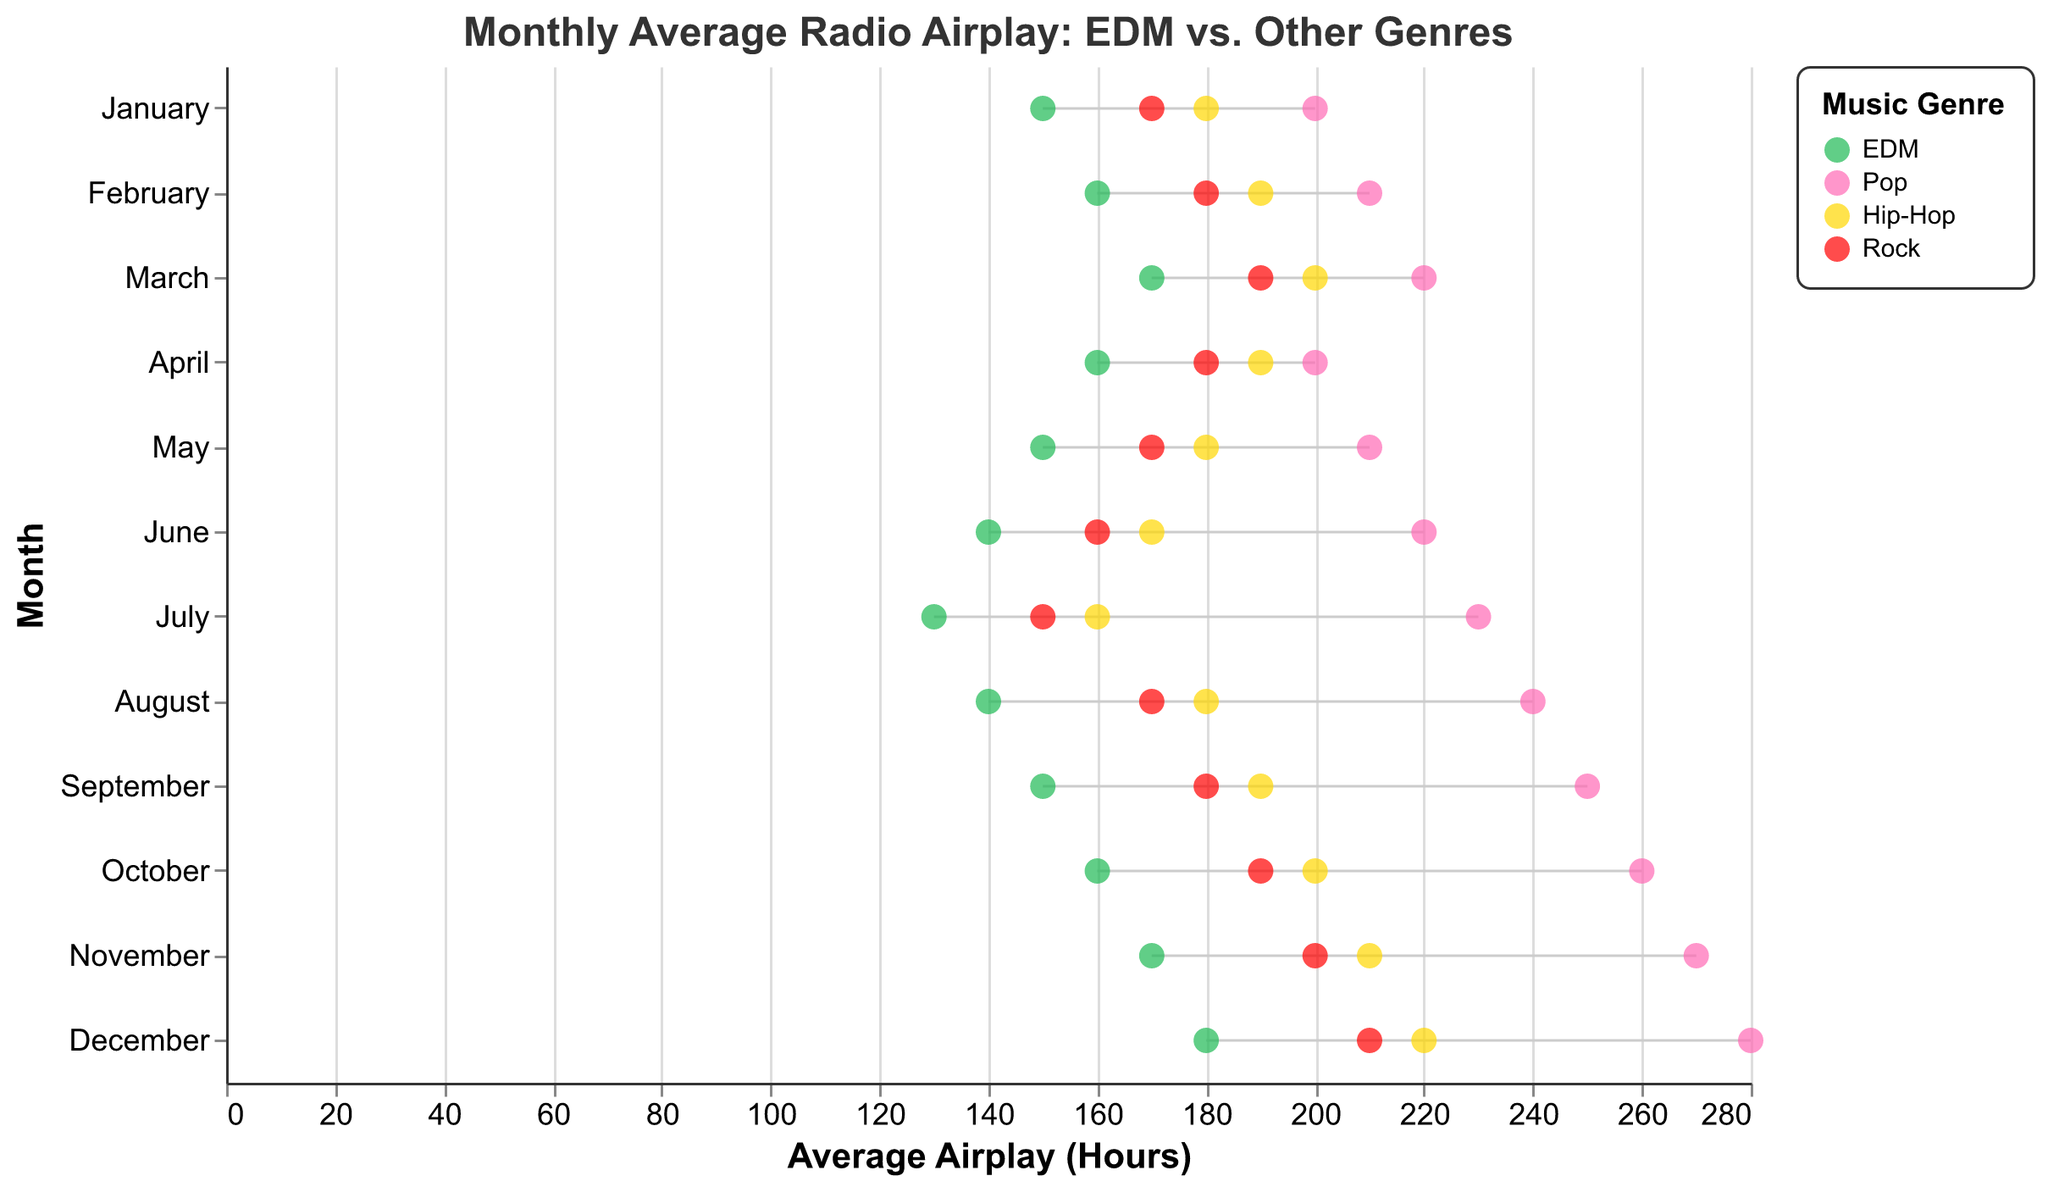What is the title of the plot? The title is located at the top of the plot and provides an overview of what the figure represents: "Monthly Average Radio Airplay: EDM vs. Other Genres".
Answer: Monthly Average Radio Airplay: EDM vs. Other Genres Which genre had the largest average airplay in December? To determine this, look at the data points in the December row and compare the values for EDM, Pop, Hip-Hop, and Rock. Each genre is represented by a different color-coded point. Pop had the highest airplay with 280 hours.
Answer: Pop How does the average airplay of EDM in January compare to that in December? Check the values for EDM in January and December. In January, EDM had 150 hours, and in December, it had 180 hours. The comparison shows an increase of 30 hours from January to December.
Answer: Increased by 30 hours What is the average airplay difference between EDM and Pop in March? Find the average airplay for EDM (170 hours) and Pop (220 hours) in March. Subtract the value of EDM from the value of Pop: 220 - 170 = 50 hours.
Answer: 50 hours Which genre consistently had the highest average airplay across all months? Review each month and identify the genre with the highest airplay for that month. Pop consistently had the highest average airplay in each month.
Answer: Pop What is the difference in average airplay hours between March and August for Hip-Hop? Check the average airplay for Hip-Hop in March (200 hours) and August (180 hours). Subtract the August value from the March value: 200 - 180 = 20 hours.
Answer: 20 hours Does the airplay trend for EDM increase or decrease over the year? Evaluate the airplay hours for EDM from January to December. Start at 150 hours in January and end at 180 hours in December. The trend shows a general increase.
Answer: Increase During which months does Rock have a higher average airplay than Hip-Hop? Compare the average airplay hours of Rock and Hip-Hop for each month. Rock has higher airplay than Hip-Hop in July (150 vs. 160 respectively).
Answer: July Which month had the smallest difference in average airplay between EDM and other genres? Calculate the difference between EDM and each of the other genres for each month and find the smallest value. April has the smallest difference; EDM is 160, and the closest genre (Hip-Hop) is 190, resulting in a difference of 30 hours.
Answer: April What is the range of average airplay hours for Pop across all months? To find the range, identify the highest (280 hours in December) and lowest (200 hours in January) average airplay for Pop. Then calculate the difference: 280 - 200 = 80 hours.
Answer: 80 hours 